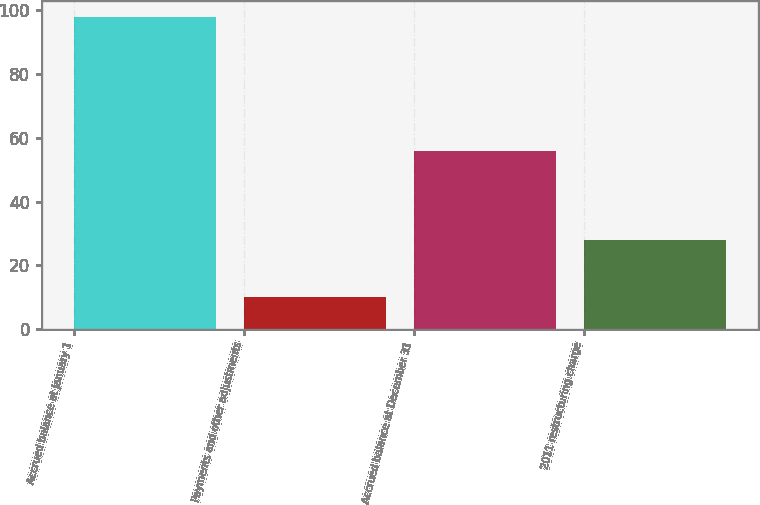<chart> <loc_0><loc_0><loc_500><loc_500><bar_chart><fcel>Accrued balance at January 1<fcel>Payments and other adjustments<fcel>Accrued balance at December 31<fcel>2011 restructuring charge<nl><fcel>98<fcel>10<fcel>56<fcel>28<nl></chart> 